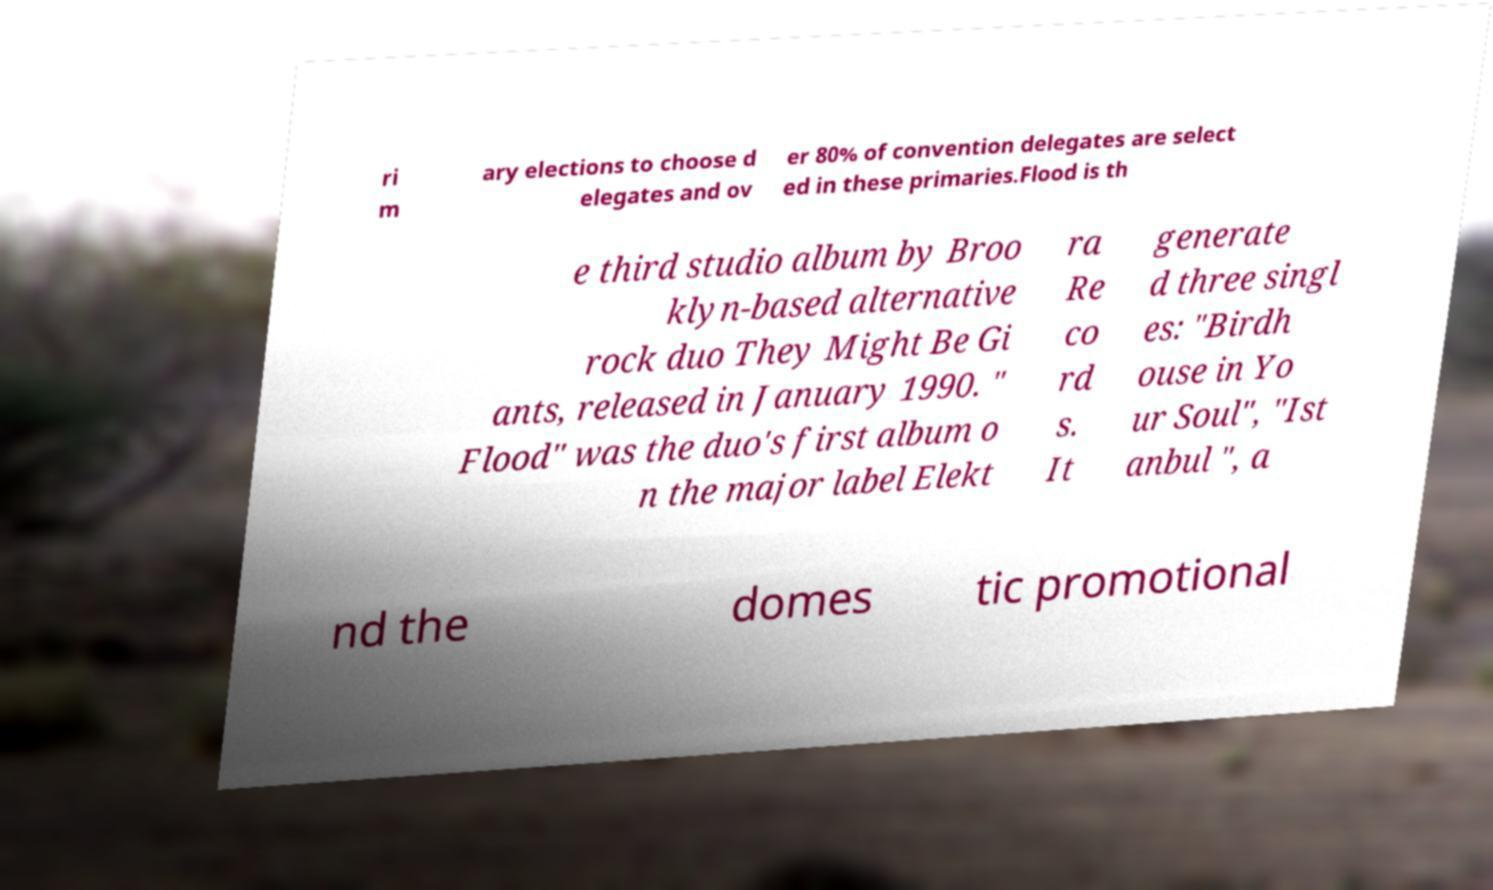What messages or text are displayed in this image? I need them in a readable, typed format. ri m ary elections to choose d elegates and ov er 80% of convention delegates are select ed in these primaries.Flood is th e third studio album by Broo klyn-based alternative rock duo They Might Be Gi ants, released in January 1990. " Flood" was the duo's first album o n the major label Elekt ra Re co rd s. It generate d three singl es: "Birdh ouse in Yo ur Soul", "Ist anbul ", a nd the domes tic promotional 